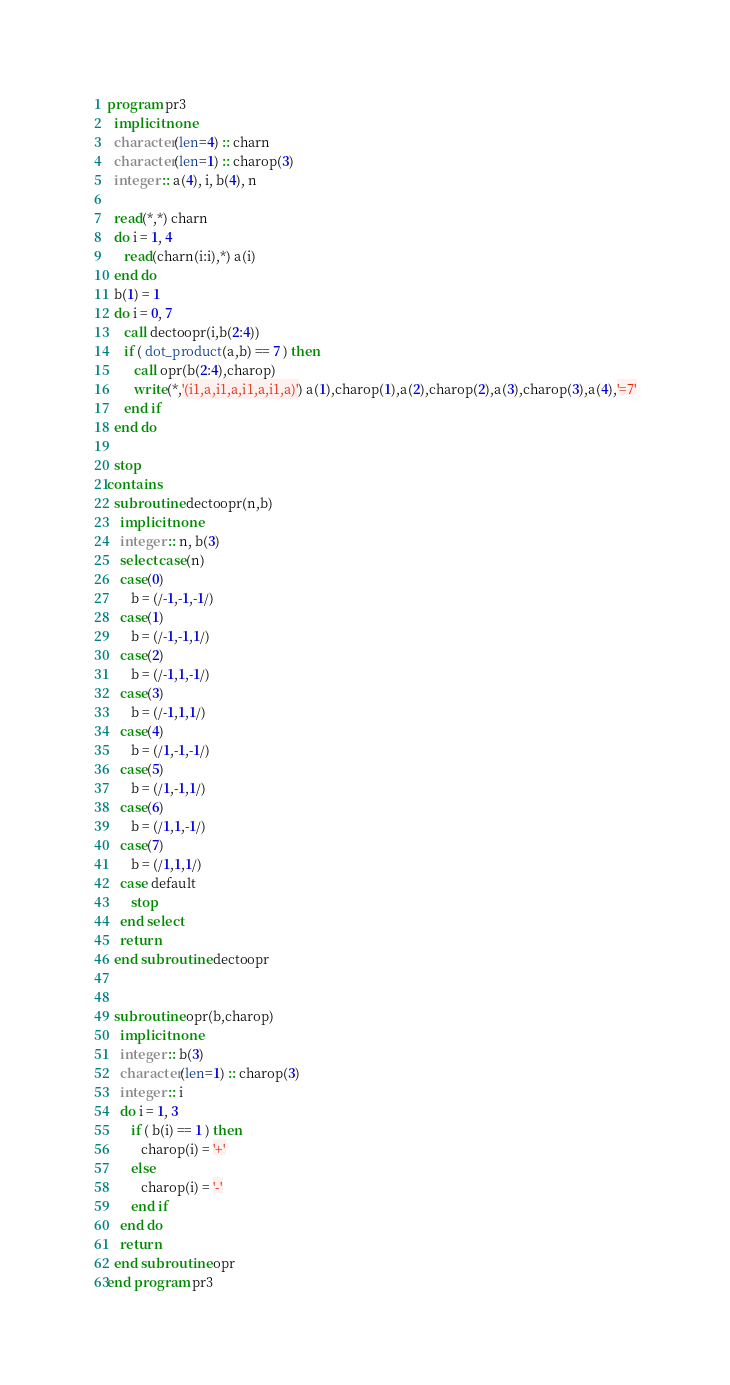Convert code to text. <code><loc_0><loc_0><loc_500><loc_500><_FORTRAN_>program pr3
  implicit none
  character(len=4) :: charn
  character(len=1) :: charop(3)
  integer :: a(4), i, b(4), n
  
  read(*,*) charn
  do i = 1, 4
     read(charn(i:i),*) a(i)
  end do
  b(1) = 1
  do i = 0, 7
     call dectoopr(i,b(2:4))
     if ( dot_product(a,b) == 7 ) then
        call opr(b(2:4),charop)
        write(*,'(i1,a,i1,a,i1,a,i1,a)') a(1),charop(1),a(2),charop(2),a(3),charop(3),a(4),'=7'
     end if
  end do
  
  stop
contains
  subroutine dectoopr(n,b)
    implicit none
    integer :: n, b(3)
    select case(n)
    case(0)
       b = (/-1,-1,-1/)
    case(1)
       b = (/-1,-1,1/)
    case(2)
       b = (/-1,1,-1/)
    case(3)
       b = (/-1,1,1/)
    case(4)
       b = (/1,-1,-1/)
    case(5)
       b = (/1,-1,1/)
    case(6)
       b = (/1,1,-1/)
    case(7)
       b = (/1,1,1/)
    case default
       stop
    end select
    return
  end subroutine dectoopr


  subroutine opr(b,charop)
    implicit none
    integer :: b(3)
    character(len=1) :: charop(3)
    integer :: i
    do i = 1, 3
       if ( b(i) == 1 ) then
          charop(i) = '+'
       else
          charop(i) = '-'
       end if
    end do
    return
  end subroutine opr
end program pr3
</code> 